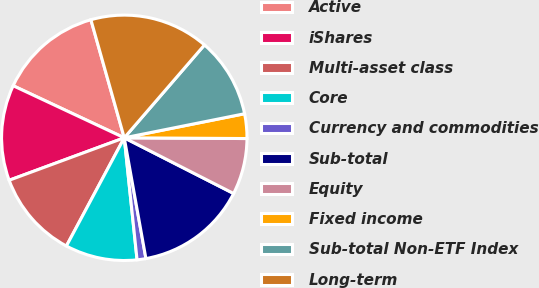<chart> <loc_0><loc_0><loc_500><loc_500><pie_chart><fcel>Active<fcel>iShares<fcel>Multi-asset class<fcel>Core<fcel>Currency and commodities<fcel>Sub-total<fcel>Equity<fcel>Fixed income<fcel>Sub-total Non-ETF Index<fcel>Long-term<nl><fcel>13.64%<fcel>12.6%<fcel>11.56%<fcel>9.48%<fcel>1.16%<fcel>14.68%<fcel>7.4%<fcel>3.24%<fcel>10.52%<fcel>15.72%<nl></chart> 